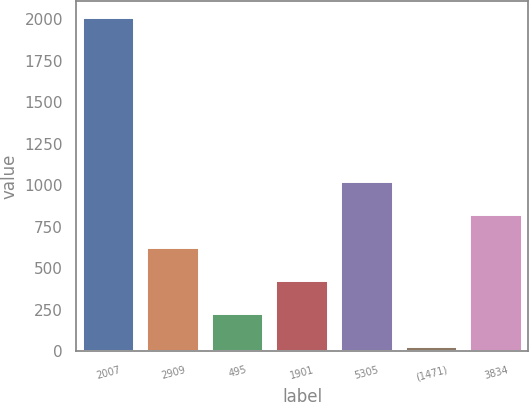Convert chart to OTSL. <chart><loc_0><loc_0><loc_500><loc_500><bar_chart><fcel>2007<fcel>2909<fcel>495<fcel>1901<fcel>5305<fcel>(1471)<fcel>3834<nl><fcel>2006<fcel>620.77<fcel>224.99<fcel>422.88<fcel>1016.55<fcel>27.1<fcel>818.66<nl></chart> 